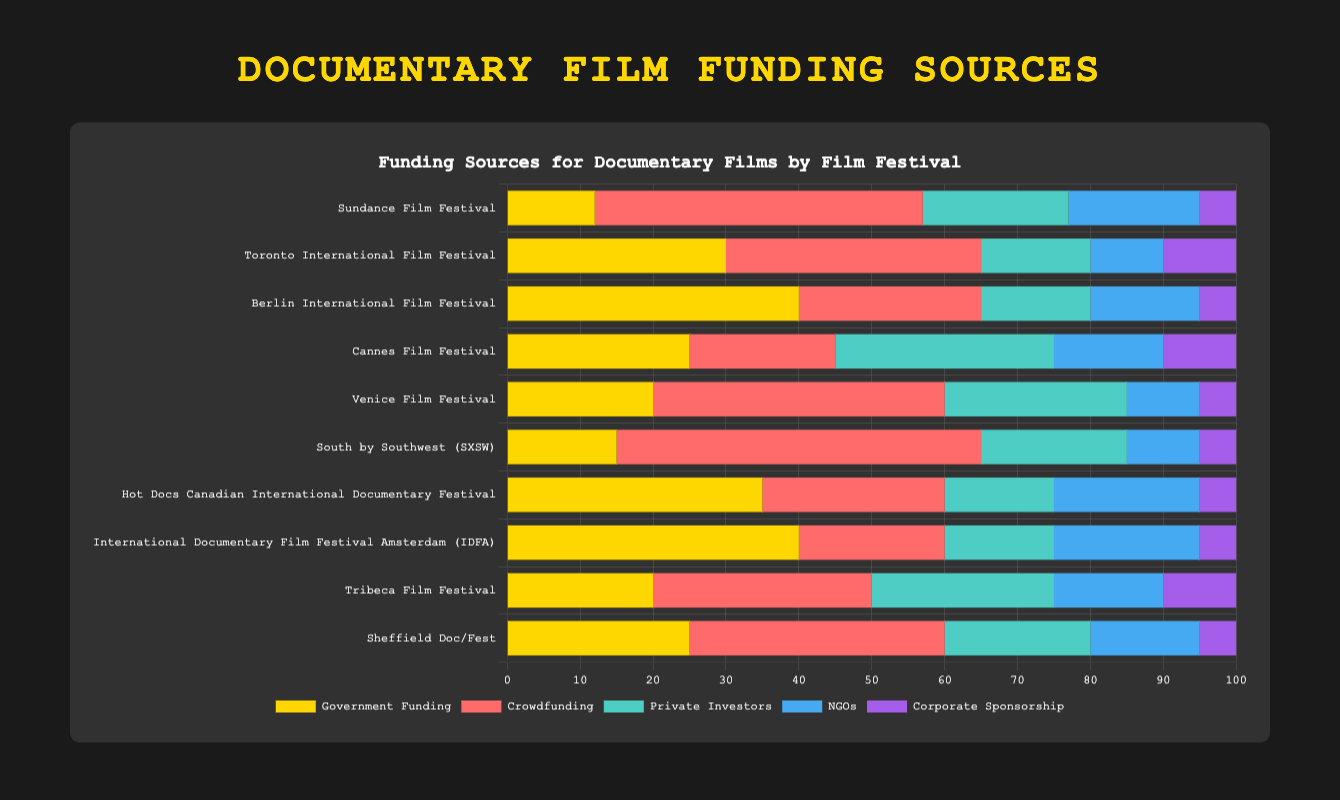Which film festival has the largest amount of crowdfunding? By looking at the red-colored segments representing Crowdfunding, South by Southwest (SXSW) has the highest segment with 50 units.
Answer: South by Southwest (SXSW) What is the total funding for the Cannes Film Festival? Add all the segments for Cannes Film Festival: Government Funding (25) + Crowdfunding (20) + Private Investors (30) + NGOs (15) + Corporate Sponsorship (10). So, the total is 25 + 20 + 30 + 15 + 10 = 100.
Answer: 100 Which funding source is least used by the Toronto International Film Festival? By looking at the smallest segment for Toronto International Film Festival, Corporate Sponsorship has the least amount with 10 units.
Answer: Corporate Sponsorship How does the Government Funding of Hot Docs compare to that of Berlin International Film Festival? Hot Docs’ Government Funding is 35 and Berlin International Film Festival’s is 40. Hence, Berlin International Film Festival has 5 more units of Government Funding.
Answer: Berlin International Film Festival has more Government Funding by 5 units Which film festival has the most balanced funding between all sources? By examining the bars for relative uniformity in length across all categories, Cannes Film Festival seems to have more uniform segment lengths among the sources, unlike other festivals where one or two sources are dominant.
Answer: Cannes Film Festival What is the sum of Private Investors and NGOS funding for Venice Film Festival? For Venice Film Festival, Private Investors funding is 25 and NGOs funding is 10. Summing them gives 25 + 10 = 35.
Answer: 35 How many total units of Government Funding are shared by Sundance, Toronto, and Berlin Film Festivals combined? Add Government Funding for these three film festivals: 12 (Sundance) + 30 (Toronto) + 40 (Berlin). The total is 12 + 30 + 40 = 82 units.
Answer: 82 Which color represents the largest funding source for South by Southwest (SXSW)? The largest segment for South by Southwest (SXSW) is Crowdfunding, represented by the red color.
Answer: Red Does the International Documentary Film Festival Amsterdam (IDFA) receive more Government Funding or Crowdfunding? And by how much? IDFA receives 40 units of Government Funding and 20 units of Crowdfunding. The difference is 40 - 20 = 20 units more for Government Funding.
Answer: Government Funding by 20 units How does the Corporate Sponsorship for International Documentary Film Festival Amsterdam (IDFA) compare to that of Sheffield Doc/Fest? Both IDFA and Sheffield Doc/Fest have Corporate Sponsorship of 5 units each, so they are equal.
Answer: Equal 